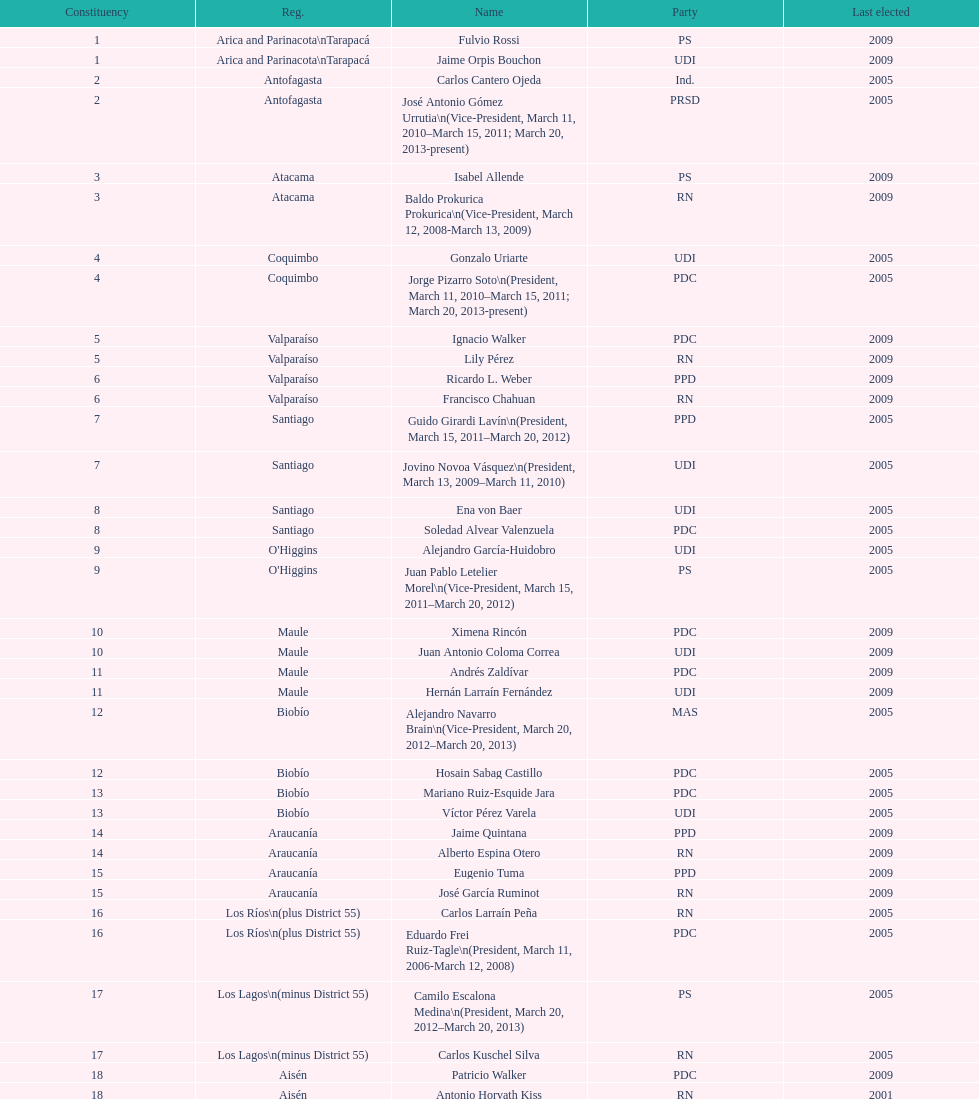When was antonio horvath kiss last elected? 2001. 